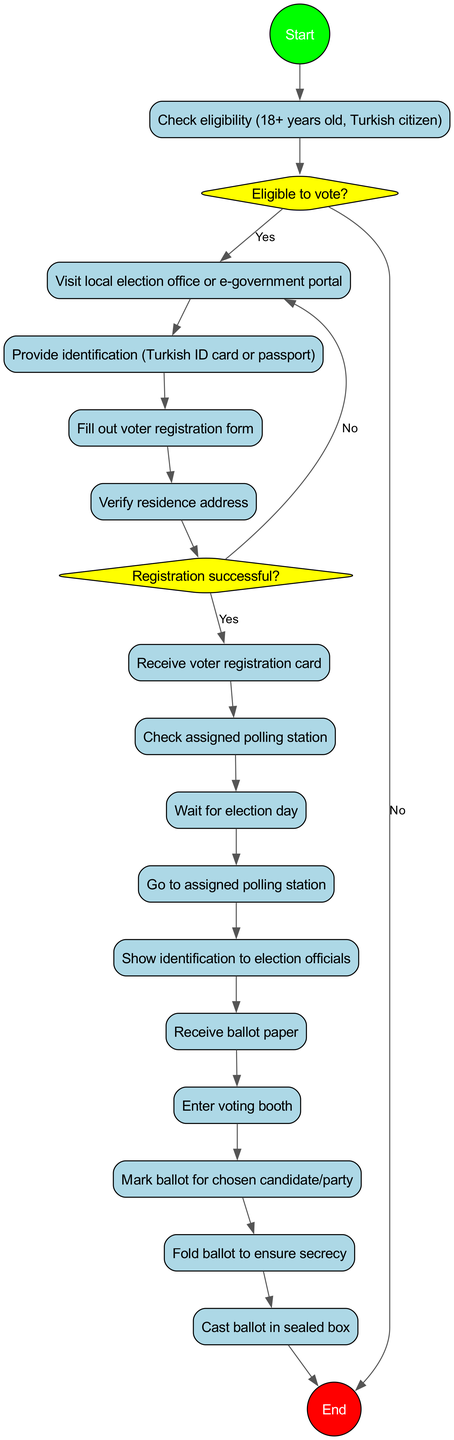What is the first activity in the process? The first activity listed in the diagram is "Check eligibility (18+ years old, Turkish citizen)." This is the first step after the initial node "Start."
Answer: Check eligibility (18+ years old, Turkish citizen) How many decision nodes are present in the diagram? The diagram includes two decision nodes, indicated by diamonds: the first regarding eligibility to vote and the second about registration success.
Answer: 2 What happens if a person is not eligible to vote? If a person is not eligible to vote, the flow leads directly to the "End" node. Thus, they do not proceed further in the process.
Answer: End What is required to proceed after the "Fill out voter registration form" activity? After filling out the voter registration form, the next activity is "Verify residence address." This indicates that verifying the address is a required step.
Answer: Verify residence address What is the output if the voter registration is unsuccessful? If the voter registration is unsuccessful, the flow goes back to "Address issues and reapply." This means the process loops back for corrections instead of proceeding to the next steps.
Answer: Address issues and reapply What is the total number of activities in the process? The diagram lists a total of 13 activities that a voter must complete, starting from checking eligibility to casting the ballot.
Answer: 13 What is the final step in the voting process? The last step in the process is "Cast ballot in sealed box," which indicates the completion of the voting action itself.
Answer: Cast ballot in sealed box What must a voter show to election officials after arriving at the polling station? Upon arriving at the assigned polling station, a voter must show their identification to election officials, indicating a verification step prior to receiving a ballot.
Answer: Show identification to election officials What is the activity that follows receiving the ballot paper? After receiving the ballot paper, the next activity is "Enter voting booth," indicating that voters must proceed to a private space to mark their votes.
Answer: Enter voting booth 